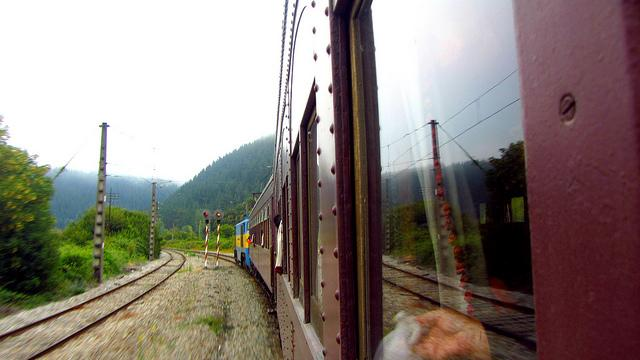Why is the train stopped?

Choices:
A) no fuel
B) broken
C) red light
D) abandoned red light 